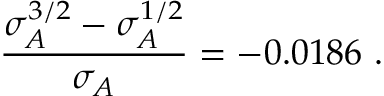Convert formula to latex. <formula><loc_0><loc_0><loc_500><loc_500>\frac { \sigma _ { A } ^ { 3 / 2 } - \sigma _ { A } ^ { 1 / 2 } } { \sigma _ { A } } = - 0 . 0 1 8 6 \ .</formula> 